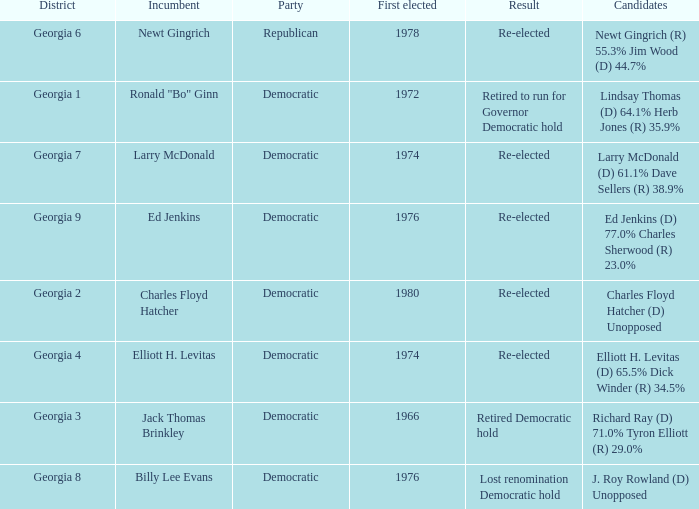Name the candidates for georgia 8 J. Roy Rowland (D) Unopposed. 